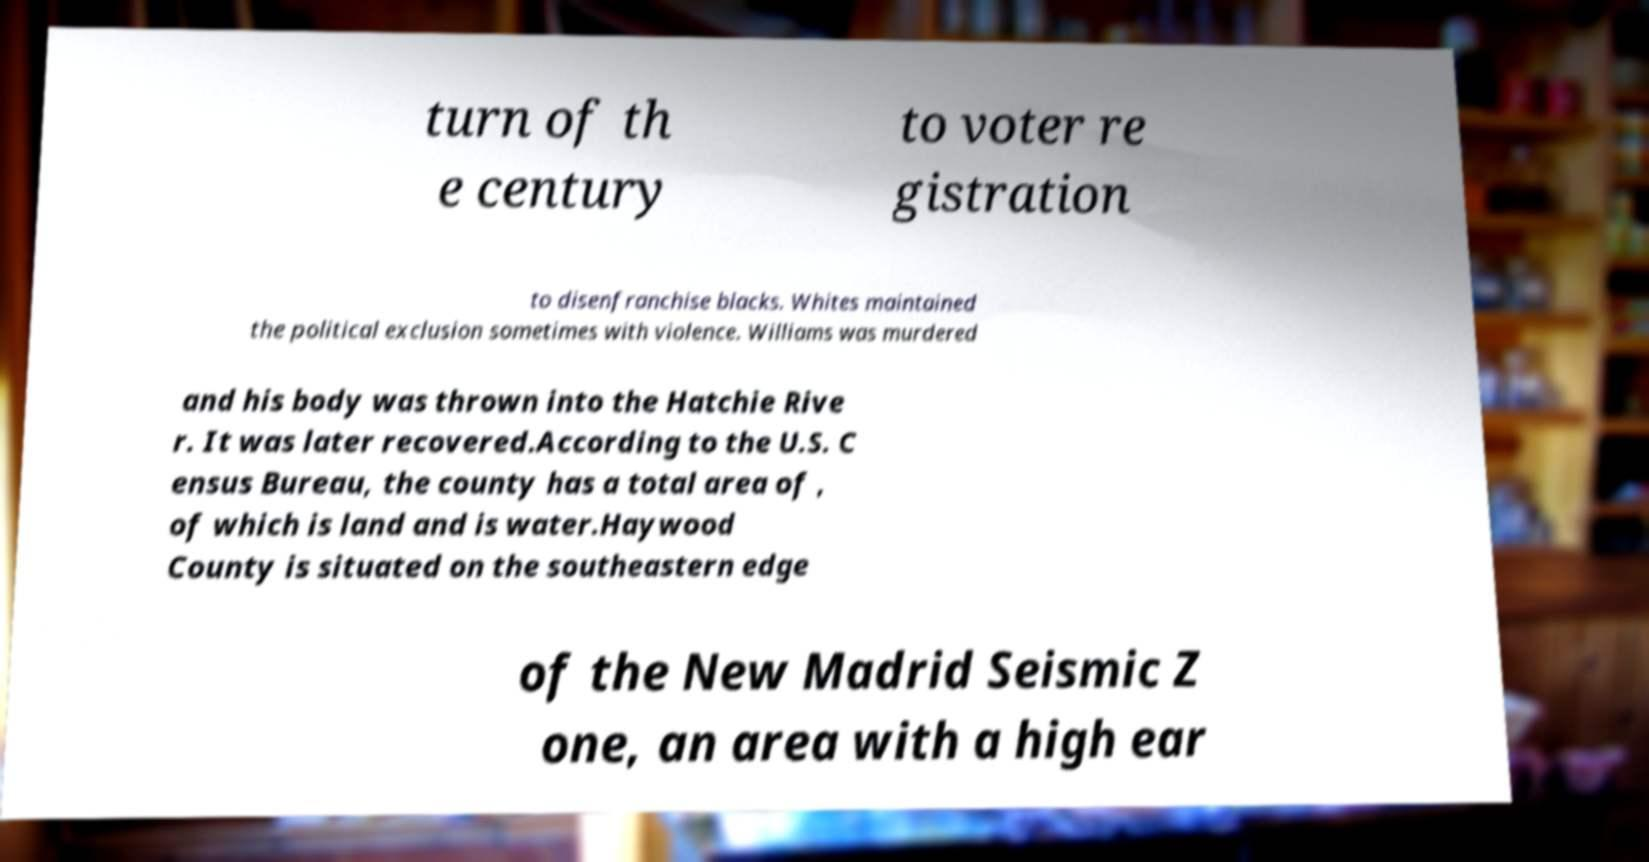Can you read and provide the text displayed in the image?This photo seems to have some interesting text. Can you extract and type it out for me? turn of th e century to voter re gistration to disenfranchise blacks. Whites maintained the political exclusion sometimes with violence. Williams was murdered and his body was thrown into the Hatchie Rive r. It was later recovered.According to the U.S. C ensus Bureau, the county has a total area of , of which is land and is water.Haywood County is situated on the southeastern edge of the New Madrid Seismic Z one, an area with a high ear 